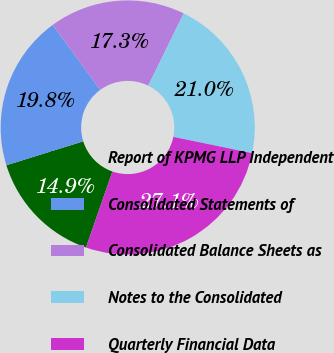Convert chart. <chart><loc_0><loc_0><loc_500><loc_500><pie_chart><fcel>Report of KPMG LLP Independent<fcel>Consolidated Statements of<fcel>Consolidated Balance Sheets as<fcel>Notes to the Consolidated<fcel>Quarterly Financial Data<nl><fcel>14.87%<fcel>19.76%<fcel>17.31%<fcel>20.98%<fcel>27.09%<nl></chart> 